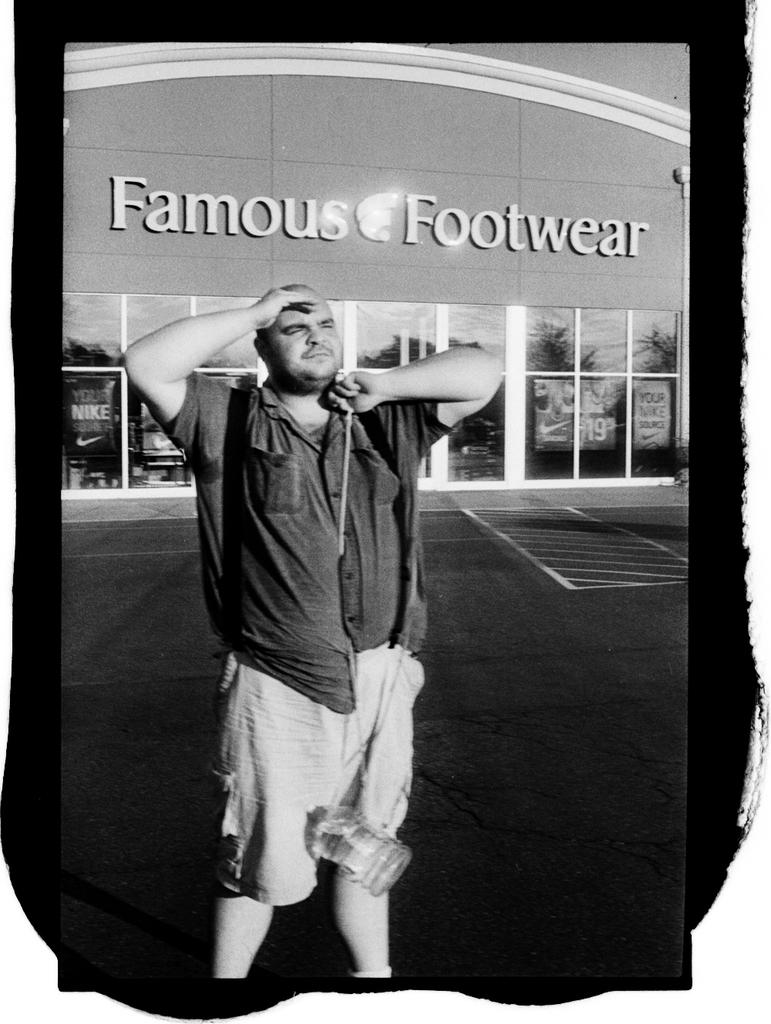What is the color scheme of the image? The image is black and white. Who is present in the image? There is a man in the image. What is the man wearing? The man is wearing a shirt and shorts. Where is the man located in the image? The man is standing on the road. What can be seen in the background of the image? There is a building in the background of the image. How many beds are visible in the image? There are no beds present in the image. What type of club is the man holding in the image? There is no club visible in the image; the man is not holding anything. 